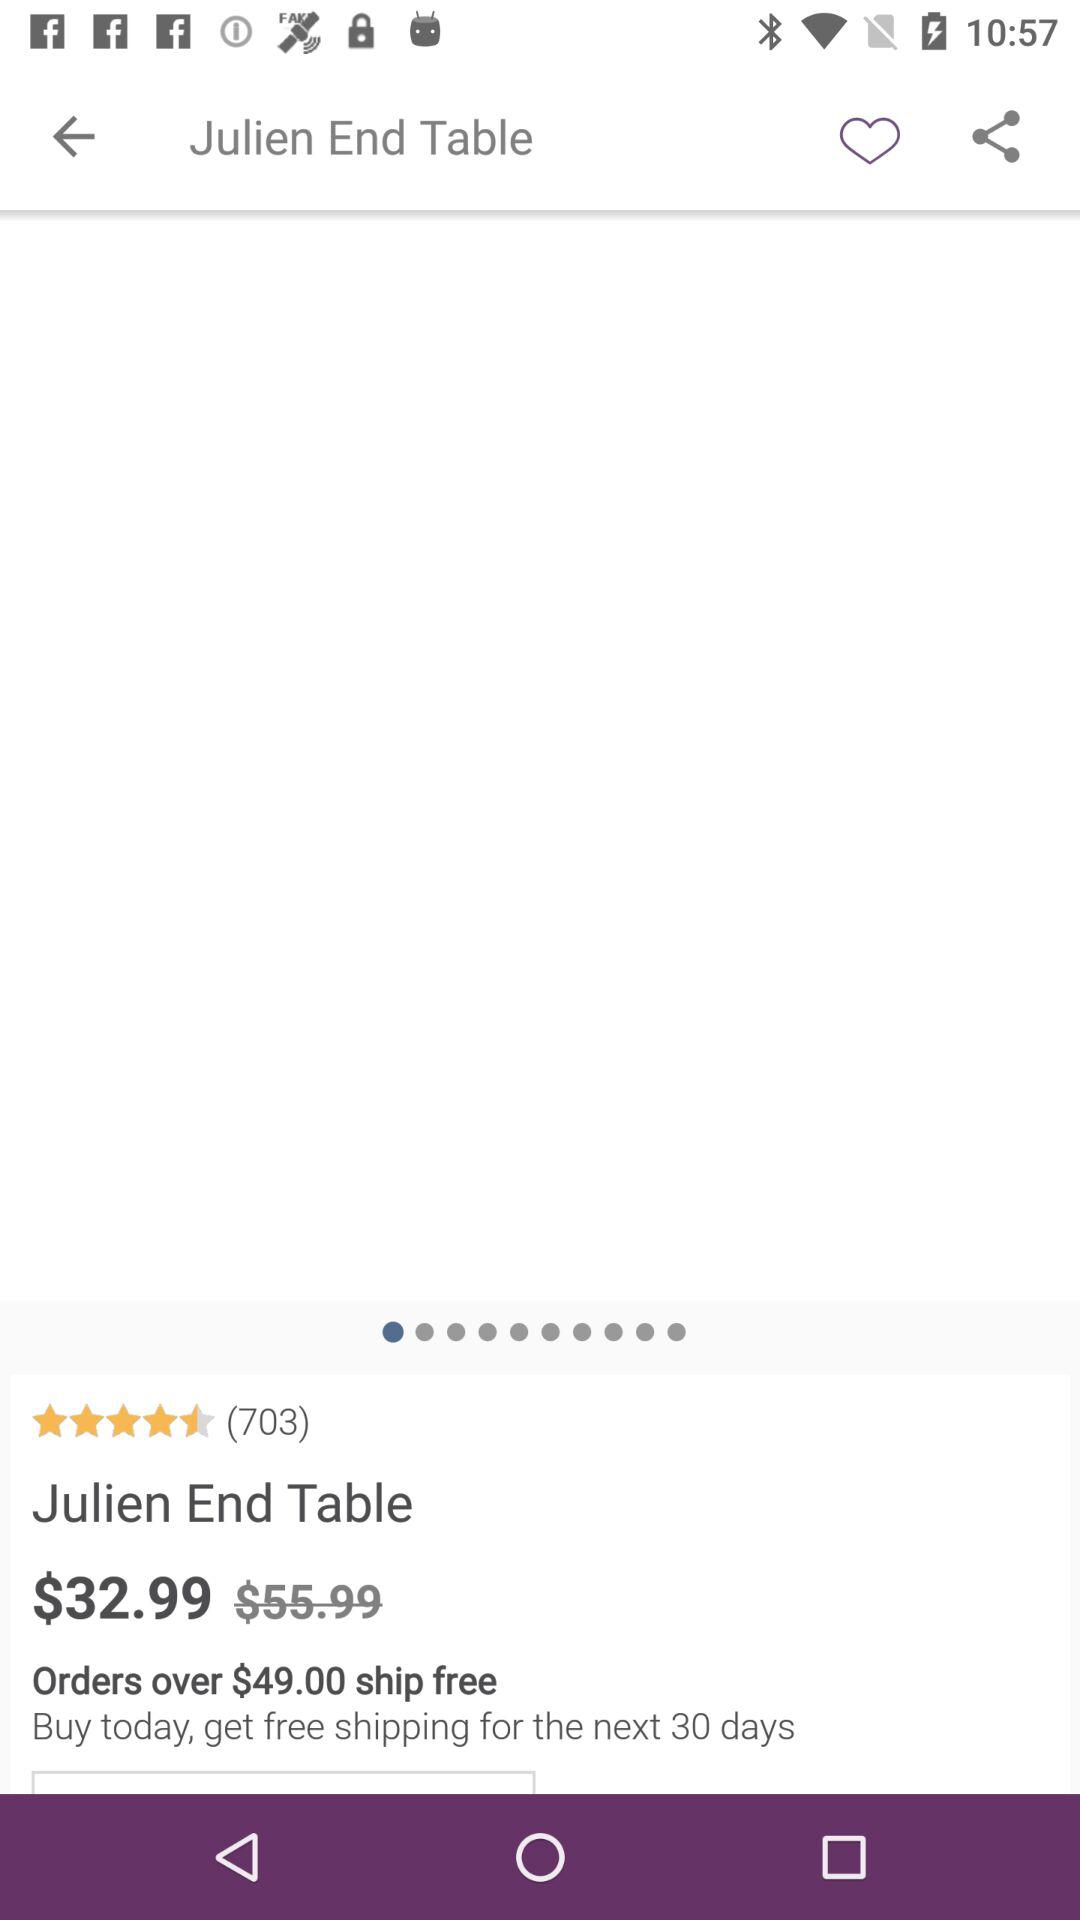What is the minimum amount of order to get free shipping? The minimum amount is $49.00. 